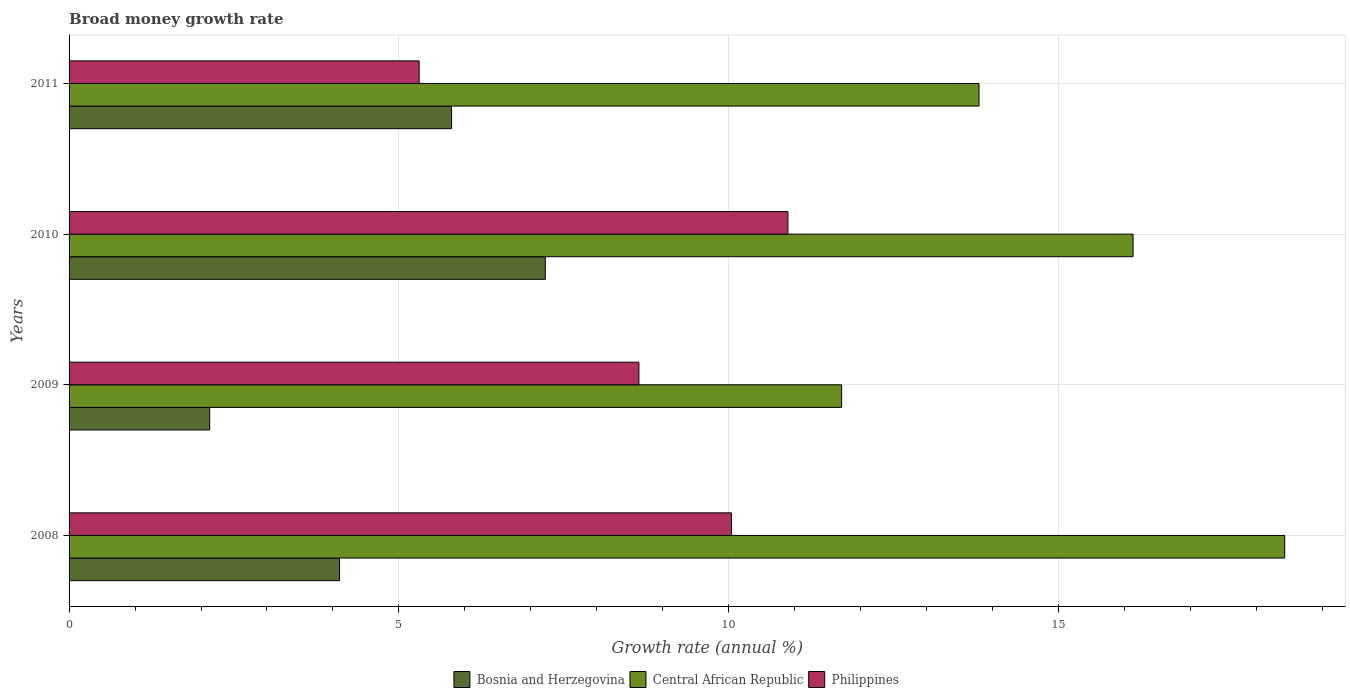Are the number of bars per tick equal to the number of legend labels?
Provide a short and direct response. Yes. Are the number of bars on each tick of the Y-axis equal?
Give a very brief answer. Yes. How many bars are there on the 1st tick from the top?
Provide a succinct answer. 3. How many bars are there on the 1st tick from the bottom?
Provide a short and direct response. 3. What is the label of the 3rd group of bars from the top?
Your answer should be very brief. 2009. In how many cases, is the number of bars for a given year not equal to the number of legend labels?
Provide a succinct answer. 0. What is the growth rate in Central African Republic in 2010?
Ensure brevity in your answer.  16.13. Across all years, what is the maximum growth rate in Philippines?
Your answer should be compact. 10.9. Across all years, what is the minimum growth rate in Central African Republic?
Keep it short and to the point. 11.71. In which year was the growth rate in Central African Republic minimum?
Your answer should be compact. 2009. What is the total growth rate in Bosnia and Herzegovina in the graph?
Ensure brevity in your answer.  19.25. What is the difference between the growth rate in Central African Republic in 2010 and that in 2011?
Your answer should be compact. 2.34. What is the difference between the growth rate in Philippines in 2011 and the growth rate in Bosnia and Herzegovina in 2008?
Your answer should be very brief. 1.21. What is the average growth rate in Central African Republic per year?
Offer a terse response. 15.02. In the year 2009, what is the difference between the growth rate in Bosnia and Herzegovina and growth rate in Central African Republic?
Your answer should be compact. -9.58. What is the ratio of the growth rate in Central African Republic in 2009 to that in 2010?
Your answer should be compact. 0.73. What is the difference between the highest and the second highest growth rate in Philippines?
Provide a short and direct response. 0.86. What is the difference between the highest and the lowest growth rate in Bosnia and Herzegovina?
Keep it short and to the point. 5.09. In how many years, is the growth rate in Central African Republic greater than the average growth rate in Central African Republic taken over all years?
Keep it short and to the point. 2. What does the 2nd bar from the top in 2008 represents?
Offer a very short reply. Central African Republic. What does the 1st bar from the bottom in 2010 represents?
Your answer should be very brief. Bosnia and Herzegovina. Is it the case that in every year, the sum of the growth rate in Bosnia and Herzegovina and growth rate in Central African Republic is greater than the growth rate in Philippines?
Your answer should be very brief. Yes. How many bars are there?
Your response must be concise. 12. Are all the bars in the graph horizontal?
Make the answer very short. Yes. How many years are there in the graph?
Give a very brief answer. 4. Are the values on the major ticks of X-axis written in scientific E-notation?
Your response must be concise. No. Where does the legend appear in the graph?
Provide a short and direct response. Bottom center. How are the legend labels stacked?
Provide a succinct answer. Horizontal. What is the title of the graph?
Give a very brief answer. Broad money growth rate. Does "France" appear as one of the legend labels in the graph?
Offer a terse response. No. What is the label or title of the X-axis?
Offer a very short reply. Growth rate (annual %). What is the Growth rate (annual %) of Bosnia and Herzegovina in 2008?
Ensure brevity in your answer.  4.1. What is the Growth rate (annual %) of Central African Republic in 2008?
Give a very brief answer. 18.43. What is the Growth rate (annual %) in Philippines in 2008?
Your answer should be very brief. 10.04. What is the Growth rate (annual %) of Bosnia and Herzegovina in 2009?
Make the answer very short. 2.13. What is the Growth rate (annual %) in Central African Republic in 2009?
Keep it short and to the point. 11.71. What is the Growth rate (annual %) in Philippines in 2009?
Keep it short and to the point. 8.64. What is the Growth rate (annual %) of Bosnia and Herzegovina in 2010?
Offer a terse response. 7.22. What is the Growth rate (annual %) in Central African Republic in 2010?
Ensure brevity in your answer.  16.13. What is the Growth rate (annual %) in Philippines in 2010?
Your response must be concise. 10.9. What is the Growth rate (annual %) of Bosnia and Herzegovina in 2011?
Offer a terse response. 5.8. What is the Growth rate (annual %) of Central African Republic in 2011?
Keep it short and to the point. 13.79. What is the Growth rate (annual %) of Philippines in 2011?
Provide a succinct answer. 5.31. Across all years, what is the maximum Growth rate (annual %) in Bosnia and Herzegovina?
Offer a terse response. 7.22. Across all years, what is the maximum Growth rate (annual %) of Central African Republic?
Provide a short and direct response. 18.43. Across all years, what is the maximum Growth rate (annual %) of Philippines?
Keep it short and to the point. 10.9. Across all years, what is the minimum Growth rate (annual %) of Bosnia and Herzegovina?
Provide a short and direct response. 2.13. Across all years, what is the minimum Growth rate (annual %) of Central African Republic?
Provide a short and direct response. 11.71. Across all years, what is the minimum Growth rate (annual %) in Philippines?
Make the answer very short. 5.31. What is the total Growth rate (annual %) in Bosnia and Herzegovina in the graph?
Your answer should be very brief. 19.25. What is the total Growth rate (annual %) in Central African Republic in the graph?
Provide a succinct answer. 60.06. What is the total Growth rate (annual %) in Philippines in the graph?
Give a very brief answer. 34.88. What is the difference between the Growth rate (annual %) in Bosnia and Herzegovina in 2008 and that in 2009?
Your answer should be compact. 1.97. What is the difference between the Growth rate (annual %) in Central African Republic in 2008 and that in 2009?
Make the answer very short. 6.72. What is the difference between the Growth rate (annual %) in Philippines in 2008 and that in 2009?
Give a very brief answer. 1.4. What is the difference between the Growth rate (annual %) in Bosnia and Herzegovina in 2008 and that in 2010?
Your answer should be very brief. -3.12. What is the difference between the Growth rate (annual %) of Central African Republic in 2008 and that in 2010?
Your response must be concise. 2.3. What is the difference between the Growth rate (annual %) of Philippines in 2008 and that in 2010?
Provide a short and direct response. -0.86. What is the difference between the Growth rate (annual %) in Bosnia and Herzegovina in 2008 and that in 2011?
Provide a short and direct response. -1.7. What is the difference between the Growth rate (annual %) of Central African Republic in 2008 and that in 2011?
Give a very brief answer. 4.63. What is the difference between the Growth rate (annual %) of Philippines in 2008 and that in 2011?
Your answer should be compact. 4.73. What is the difference between the Growth rate (annual %) of Bosnia and Herzegovina in 2009 and that in 2010?
Provide a short and direct response. -5.09. What is the difference between the Growth rate (annual %) in Central African Republic in 2009 and that in 2010?
Ensure brevity in your answer.  -4.42. What is the difference between the Growth rate (annual %) in Philippines in 2009 and that in 2010?
Give a very brief answer. -2.26. What is the difference between the Growth rate (annual %) of Bosnia and Herzegovina in 2009 and that in 2011?
Provide a short and direct response. -3.67. What is the difference between the Growth rate (annual %) in Central African Republic in 2009 and that in 2011?
Your answer should be compact. -2.08. What is the difference between the Growth rate (annual %) in Philippines in 2009 and that in 2011?
Give a very brief answer. 3.33. What is the difference between the Growth rate (annual %) of Bosnia and Herzegovina in 2010 and that in 2011?
Provide a short and direct response. 1.42. What is the difference between the Growth rate (annual %) in Central African Republic in 2010 and that in 2011?
Your answer should be very brief. 2.33. What is the difference between the Growth rate (annual %) in Philippines in 2010 and that in 2011?
Give a very brief answer. 5.59. What is the difference between the Growth rate (annual %) of Bosnia and Herzegovina in 2008 and the Growth rate (annual %) of Central African Republic in 2009?
Give a very brief answer. -7.61. What is the difference between the Growth rate (annual %) of Bosnia and Herzegovina in 2008 and the Growth rate (annual %) of Philippines in 2009?
Ensure brevity in your answer.  -4.54. What is the difference between the Growth rate (annual %) of Central African Republic in 2008 and the Growth rate (annual %) of Philippines in 2009?
Offer a very short reply. 9.79. What is the difference between the Growth rate (annual %) of Bosnia and Herzegovina in 2008 and the Growth rate (annual %) of Central African Republic in 2010?
Your answer should be compact. -12.03. What is the difference between the Growth rate (annual %) of Bosnia and Herzegovina in 2008 and the Growth rate (annual %) of Philippines in 2010?
Provide a short and direct response. -6.8. What is the difference between the Growth rate (annual %) of Central African Republic in 2008 and the Growth rate (annual %) of Philippines in 2010?
Keep it short and to the point. 7.53. What is the difference between the Growth rate (annual %) of Bosnia and Herzegovina in 2008 and the Growth rate (annual %) of Central African Republic in 2011?
Keep it short and to the point. -9.69. What is the difference between the Growth rate (annual %) in Bosnia and Herzegovina in 2008 and the Growth rate (annual %) in Philippines in 2011?
Offer a very short reply. -1.21. What is the difference between the Growth rate (annual %) of Central African Republic in 2008 and the Growth rate (annual %) of Philippines in 2011?
Offer a terse response. 13.12. What is the difference between the Growth rate (annual %) of Bosnia and Herzegovina in 2009 and the Growth rate (annual %) of Central African Republic in 2010?
Give a very brief answer. -14. What is the difference between the Growth rate (annual %) in Bosnia and Herzegovina in 2009 and the Growth rate (annual %) in Philippines in 2010?
Your response must be concise. -8.77. What is the difference between the Growth rate (annual %) in Central African Republic in 2009 and the Growth rate (annual %) in Philippines in 2010?
Ensure brevity in your answer.  0.81. What is the difference between the Growth rate (annual %) in Bosnia and Herzegovina in 2009 and the Growth rate (annual %) in Central African Republic in 2011?
Make the answer very short. -11.66. What is the difference between the Growth rate (annual %) of Bosnia and Herzegovina in 2009 and the Growth rate (annual %) of Philippines in 2011?
Offer a very short reply. -3.18. What is the difference between the Growth rate (annual %) of Central African Republic in 2009 and the Growth rate (annual %) of Philippines in 2011?
Your answer should be compact. 6.4. What is the difference between the Growth rate (annual %) in Bosnia and Herzegovina in 2010 and the Growth rate (annual %) in Central African Republic in 2011?
Your answer should be very brief. -6.57. What is the difference between the Growth rate (annual %) in Bosnia and Herzegovina in 2010 and the Growth rate (annual %) in Philippines in 2011?
Your answer should be compact. 1.91. What is the difference between the Growth rate (annual %) in Central African Republic in 2010 and the Growth rate (annual %) in Philippines in 2011?
Your answer should be very brief. 10.82. What is the average Growth rate (annual %) in Bosnia and Herzegovina per year?
Give a very brief answer. 4.81. What is the average Growth rate (annual %) of Central African Republic per year?
Your answer should be very brief. 15.02. What is the average Growth rate (annual %) in Philippines per year?
Keep it short and to the point. 8.72. In the year 2008, what is the difference between the Growth rate (annual %) in Bosnia and Herzegovina and Growth rate (annual %) in Central African Republic?
Your response must be concise. -14.33. In the year 2008, what is the difference between the Growth rate (annual %) of Bosnia and Herzegovina and Growth rate (annual %) of Philippines?
Ensure brevity in your answer.  -5.94. In the year 2008, what is the difference between the Growth rate (annual %) in Central African Republic and Growth rate (annual %) in Philippines?
Give a very brief answer. 8.39. In the year 2009, what is the difference between the Growth rate (annual %) of Bosnia and Herzegovina and Growth rate (annual %) of Central African Republic?
Give a very brief answer. -9.58. In the year 2009, what is the difference between the Growth rate (annual %) of Bosnia and Herzegovina and Growth rate (annual %) of Philippines?
Provide a short and direct response. -6.51. In the year 2009, what is the difference between the Growth rate (annual %) of Central African Republic and Growth rate (annual %) of Philippines?
Give a very brief answer. 3.07. In the year 2010, what is the difference between the Growth rate (annual %) of Bosnia and Herzegovina and Growth rate (annual %) of Central African Republic?
Give a very brief answer. -8.91. In the year 2010, what is the difference between the Growth rate (annual %) in Bosnia and Herzegovina and Growth rate (annual %) in Philippines?
Make the answer very short. -3.68. In the year 2010, what is the difference between the Growth rate (annual %) of Central African Republic and Growth rate (annual %) of Philippines?
Give a very brief answer. 5.23. In the year 2011, what is the difference between the Growth rate (annual %) of Bosnia and Herzegovina and Growth rate (annual %) of Central African Republic?
Make the answer very short. -8. In the year 2011, what is the difference between the Growth rate (annual %) in Bosnia and Herzegovina and Growth rate (annual %) in Philippines?
Offer a very short reply. 0.49. In the year 2011, what is the difference between the Growth rate (annual %) in Central African Republic and Growth rate (annual %) in Philippines?
Your answer should be very brief. 8.49. What is the ratio of the Growth rate (annual %) in Bosnia and Herzegovina in 2008 to that in 2009?
Provide a succinct answer. 1.92. What is the ratio of the Growth rate (annual %) of Central African Republic in 2008 to that in 2009?
Your response must be concise. 1.57. What is the ratio of the Growth rate (annual %) in Philippines in 2008 to that in 2009?
Offer a very short reply. 1.16. What is the ratio of the Growth rate (annual %) of Bosnia and Herzegovina in 2008 to that in 2010?
Keep it short and to the point. 0.57. What is the ratio of the Growth rate (annual %) in Central African Republic in 2008 to that in 2010?
Keep it short and to the point. 1.14. What is the ratio of the Growth rate (annual %) in Philippines in 2008 to that in 2010?
Your response must be concise. 0.92. What is the ratio of the Growth rate (annual %) of Bosnia and Herzegovina in 2008 to that in 2011?
Your answer should be very brief. 0.71. What is the ratio of the Growth rate (annual %) of Central African Republic in 2008 to that in 2011?
Make the answer very short. 1.34. What is the ratio of the Growth rate (annual %) in Philippines in 2008 to that in 2011?
Offer a terse response. 1.89. What is the ratio of the Growth rate (annual %) of Bosnia and Herzegovina in 2009 to that in 2010?
Give a very brief answer. 0.3. What is the ratio of the Growth rate (annual %) in Central African Republic in 2009 to that in 2010?
Your answer should be very brief. 0.73. What is the ratio of the Growth rate (annual %) of Philippines in 2009 to that in 2010?
Offer a very short reply. 0.79. What is the ratio of the Growth rate (annual %) in Bosnia and Herzegovina in 2009 to that in 2011?
Ensure brevity in your answer.  0.37. What is the ratio of the Growth rate (annual %) of Central African Republic in 2009 to that in 2011?
Provide a short and direct response. 0.85. What is the ratio of the Growth rate (annual %) of Philippines in 2009 to that in 2011?
Offer a terse response. 1.63. What is the ratio of the Growth rate (annual %) of Bosnia and Herzegovina in 2010 to that in 2011?
Offer a terse response. 1.25. What is the ratio of the Growth rate (annual %) in Central African Republic in 2010 to that in 2011?
Offer a very short reply. 1.17. What is the ratio of the Growth rate (annual %) in Philippines in 2010 to that in 2011?
Your response must be concise. 2.05. What is the difference between the highest and the second highest Growth rate (annual %) in Bosnia and Herzegovina?
Your response must be concise. 1.42. What is the difference between the highest and the second highest Growth rate (annual %) in Central African Republic?
Ensure brevity in your answer.  2.3. What is the difference between the highest and the second highest Growth rate (annual %) in Philippines?
Keep it short and to the point. 0.86. What is the difference between the highest and the lowest Growth rate (annual %) in Bosnia and Herzegovina?
Your answer should be very brief. 5.09. What is the difference between the highest and the lowest Growth rate (annual %) of Central African Republic?
Keep it short and to the point. 6.72. What is the difference between the highest and the lowest Growth rate (annual %) in Philippines?
Your response must be concise. 5.59. 